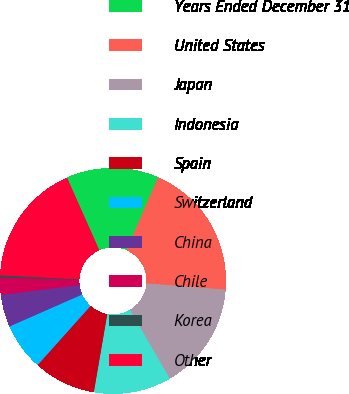<chart> <loc_0><loc_0><loc_500><loc_500><pie_chart><fcel>Years Ended December 31<fcel>United States<fcel>Japan<fcel>Indonesia<fcel>Spain<fcel>Switzerland<fcel>China<fcel>Chile<fcel>Korea<fcel>Other<nl><fcel>13.23%<fcel>19.69%<fcel>15.38%<fcel>11.08%<fcel>8.92%<fcel>6.77%<fcel>4.62%<fcel>2.46%<fcel>0.31%<fcel>17.54%<nl></chart> 